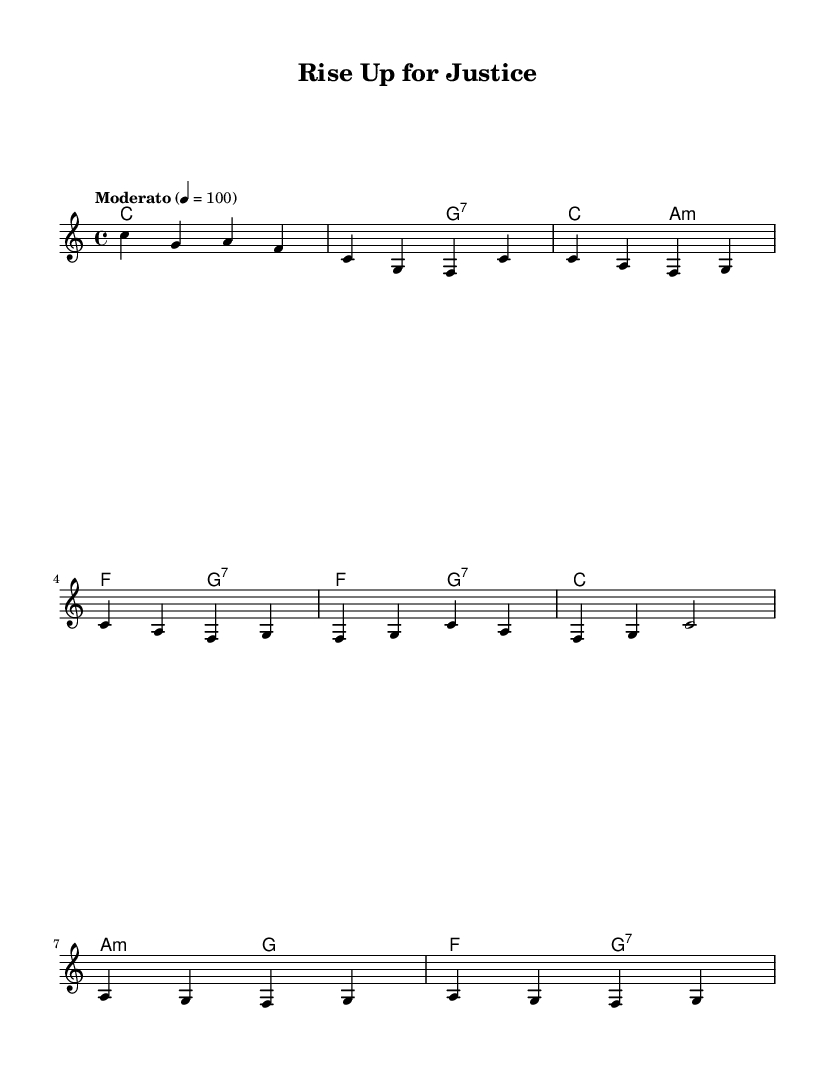What is the key signature of this music? The key signature indicated in the sheet music is C major, which is represented by the absence of any sharps or flats.
Answer: C major What is the time signature of this music? The time signature shown in the sheet music is 4/4, indicated at the beginning of the score. This means there are four beats in a measure, and the quarter note gets one beat.
Answer: 4/4 What is the tempo marking for this music? The tempo marking indicates that the piece should be played at a "Moderato" pace, which is considered a moderate speed of 100 beats per minute.
Answer: Moderato How many measures are in the chorus section? The chorus section consists of two measures, as indicated by the grouping and note structure in the sheet music.
Answer: 2 What is the first note of the melody? The first note of the melody is a C, found in the introductory measure, which is the initial pitch of the composition.
Answer: C What type of harmony is used in the bridge section? The harmony in the bridge section primarily alternates between minor and dominant 7th chords, showing a contrast characteristic of the soul genre to create emotional depth.
Answer: Minor and dominant 7th What is the significance of the placeholder lyrics? The placeholder lyrics serve as a visual indication of where lyrics would be set, often relevant in soul music for its expressive vocal delivery, allowing performers to focus on melody and harmony as they integrate lyrics later.
Answer: Placeholder lyrics 